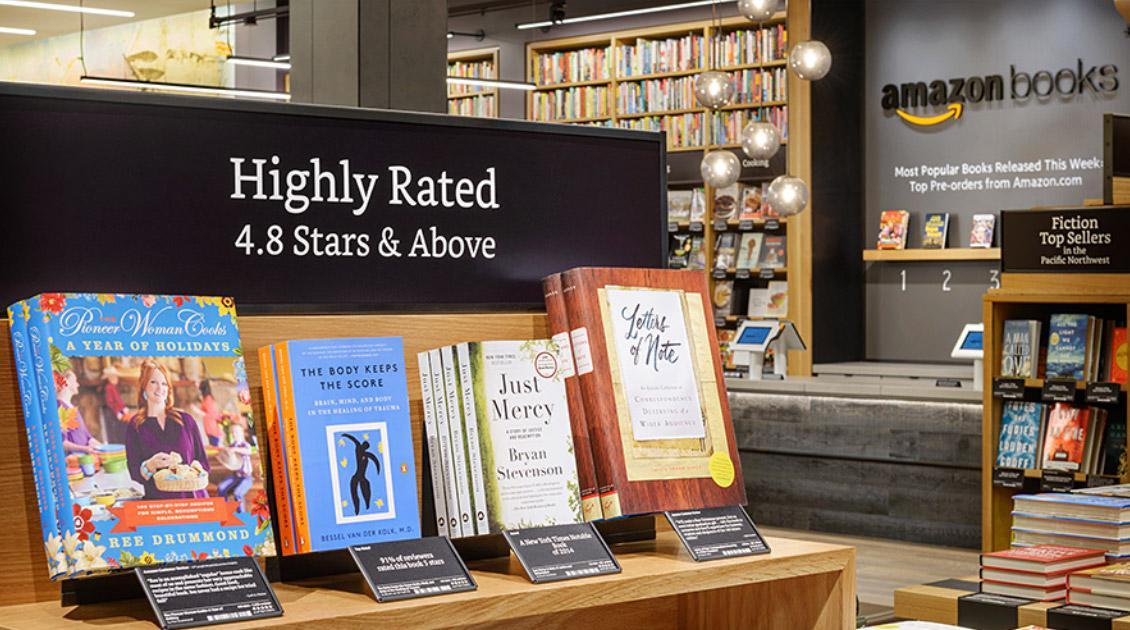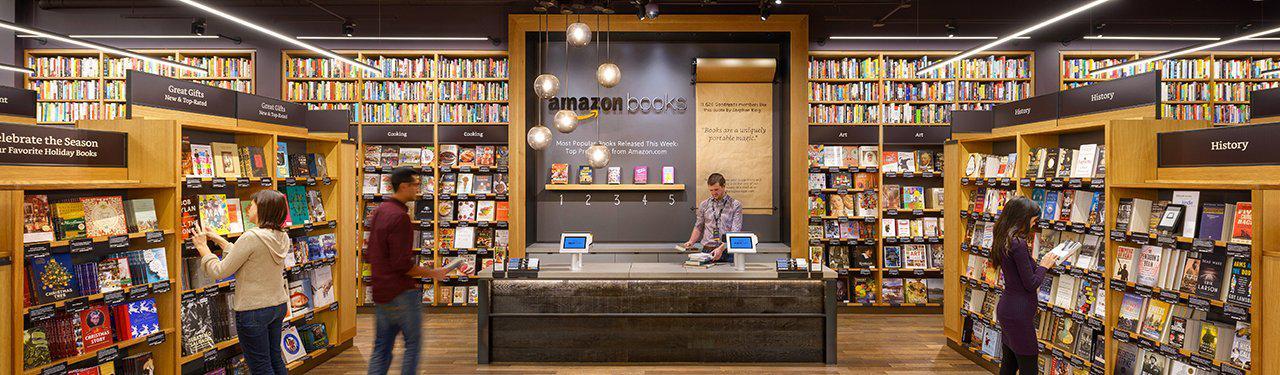The first image is the image on the left, the second image is the image on the right. For the images displayed, is the sentence "There are people looking at books in the bookstore in both images." factually correct? Answer yes or no. No. 